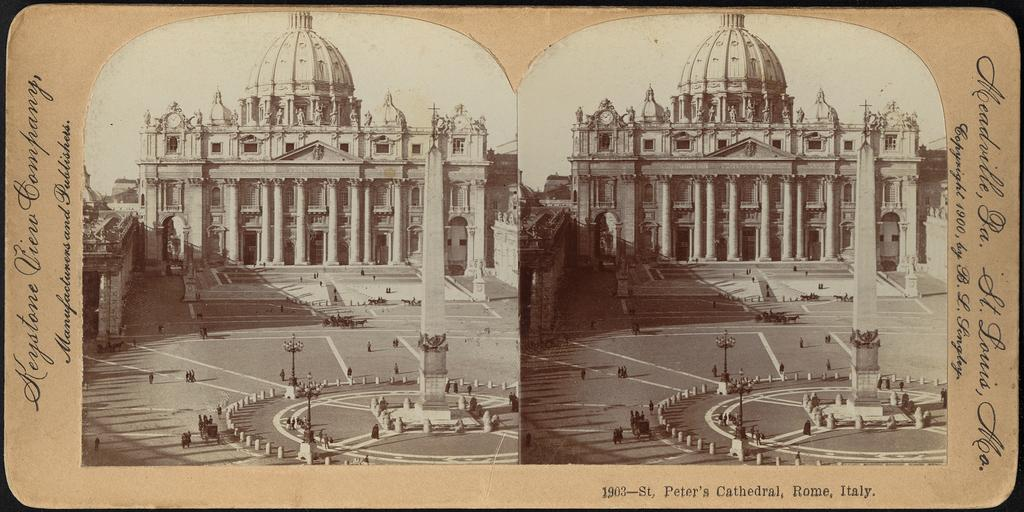<image>
Give a short and clear explanation of the subsequent image. A sepia colored photo of St. Peter's Cathedral in Italy is visible. 